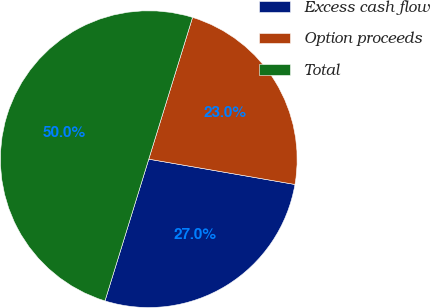Convert chart. <chart><loc_0><loc_0><loc_500><loc_500><pie_chart><fcel>Excess cash flow<fcel>Option proceeds<fcel>Total<nl><fcel>27.04%<fcel>22.96%<fcel>50.0%<nl></chart> 